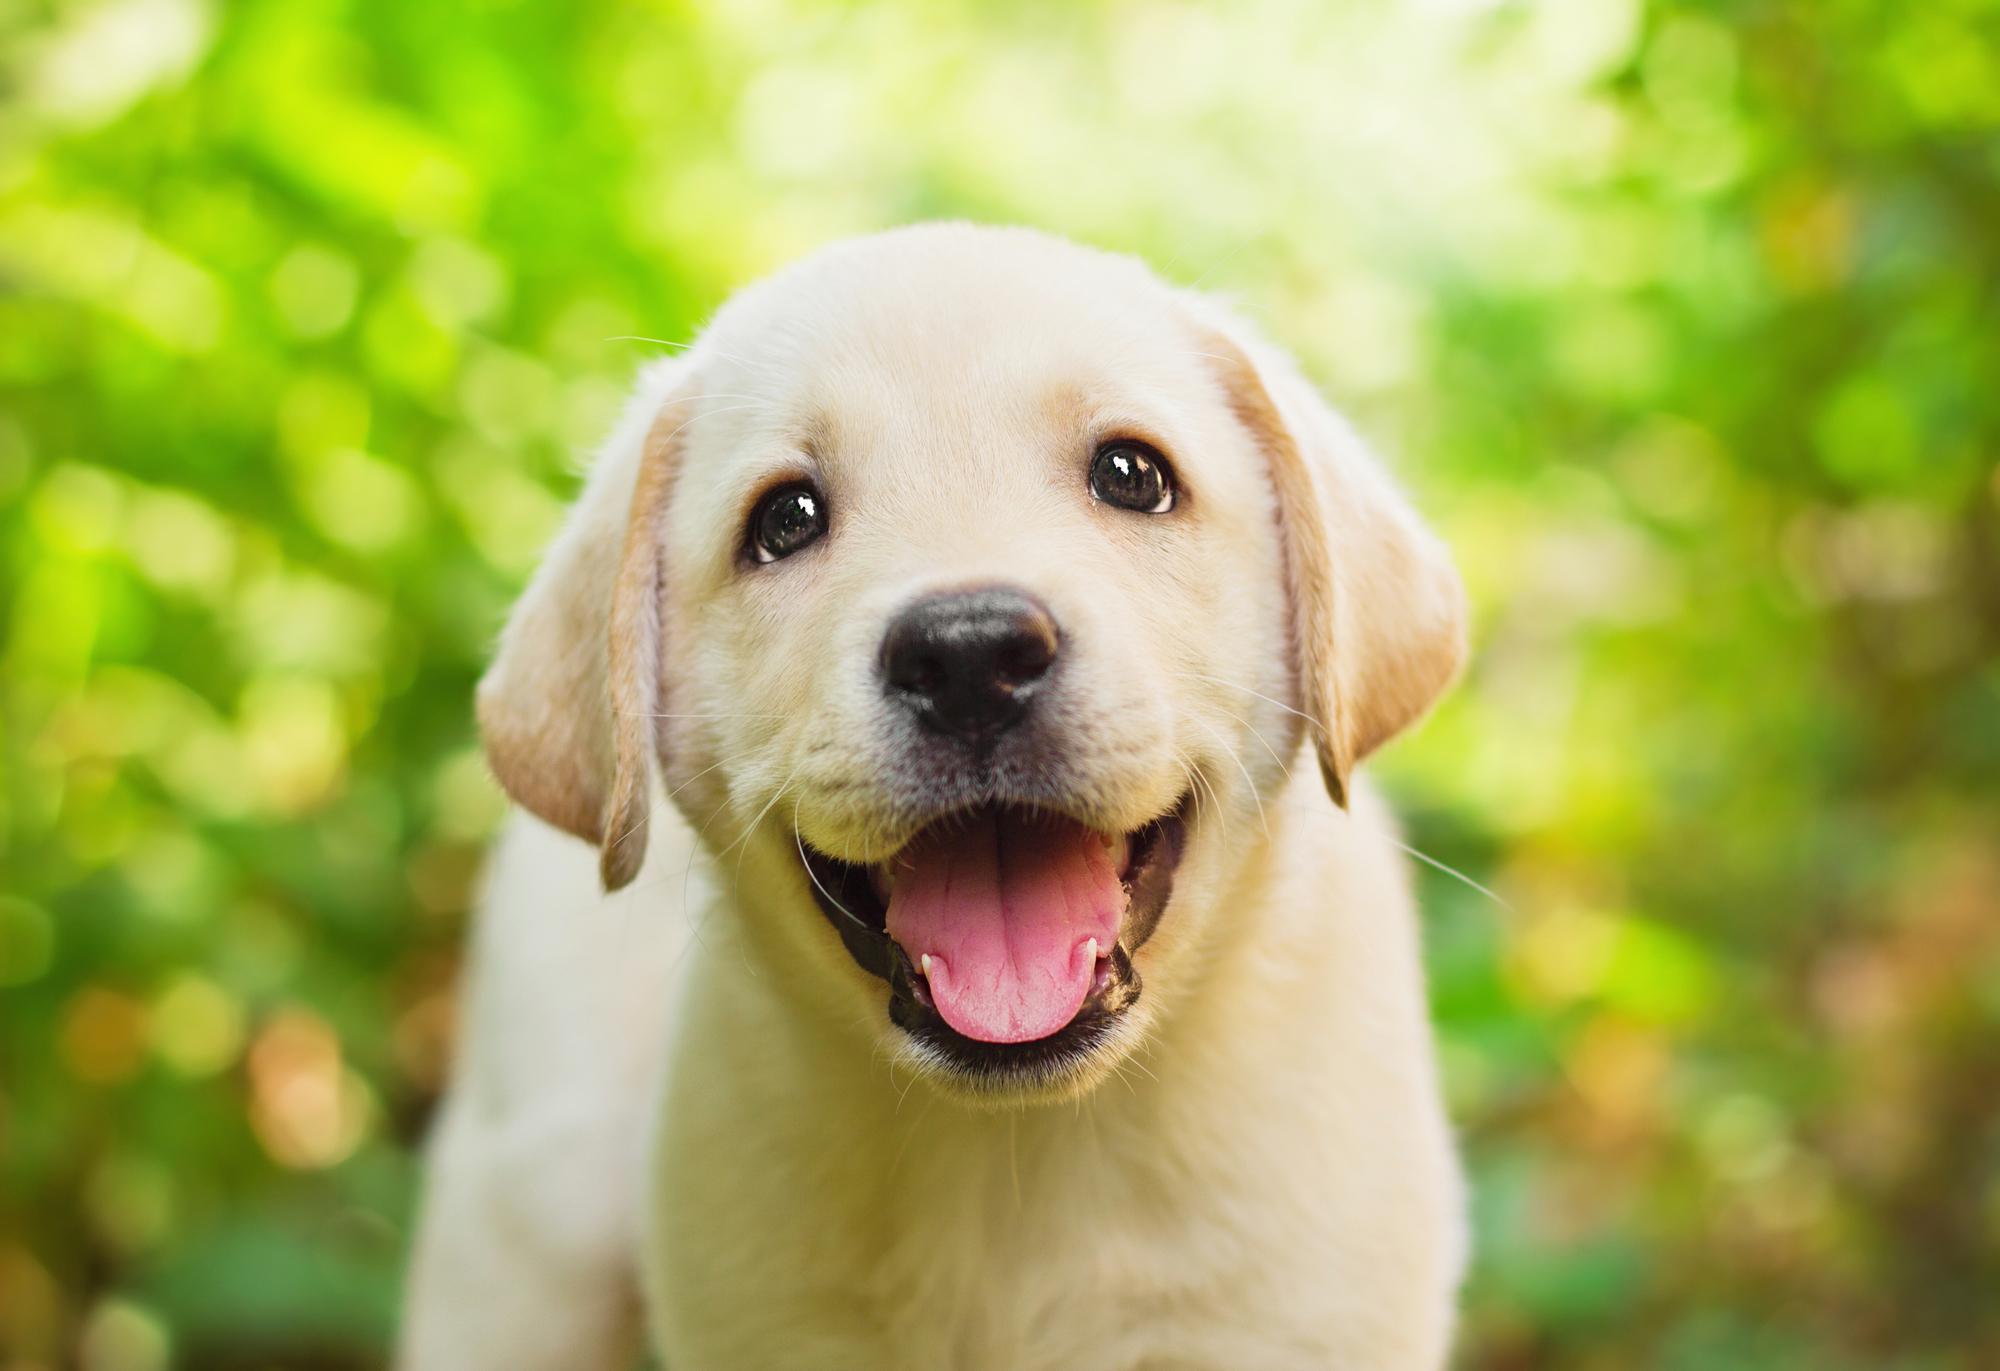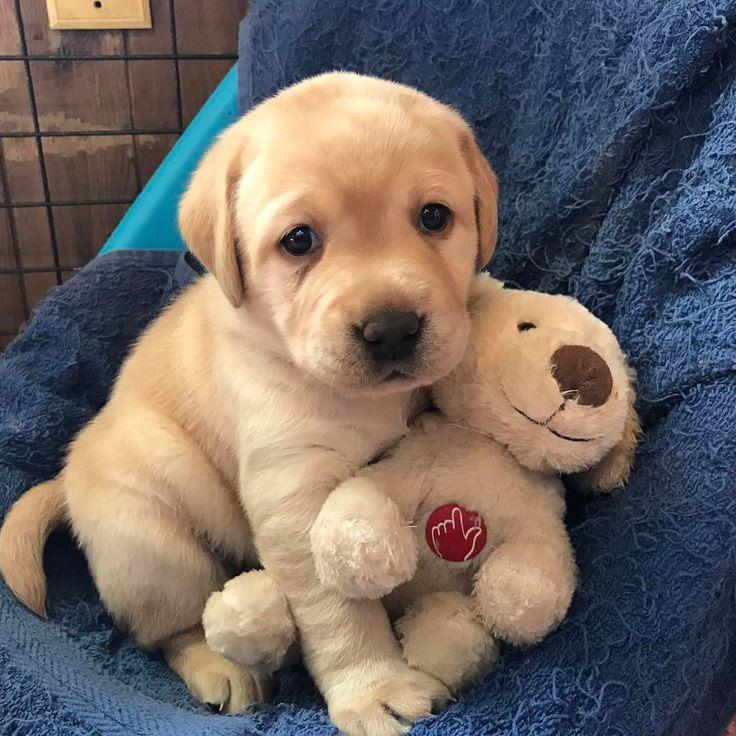The first image is the image on the left, the second image is the image on the right. Evaluate the accuracy of this statement regarding the images: "In 1 of the images, 1 dog is seated on an artificial surface.". Is it true? Answer yes or no. Yes. 